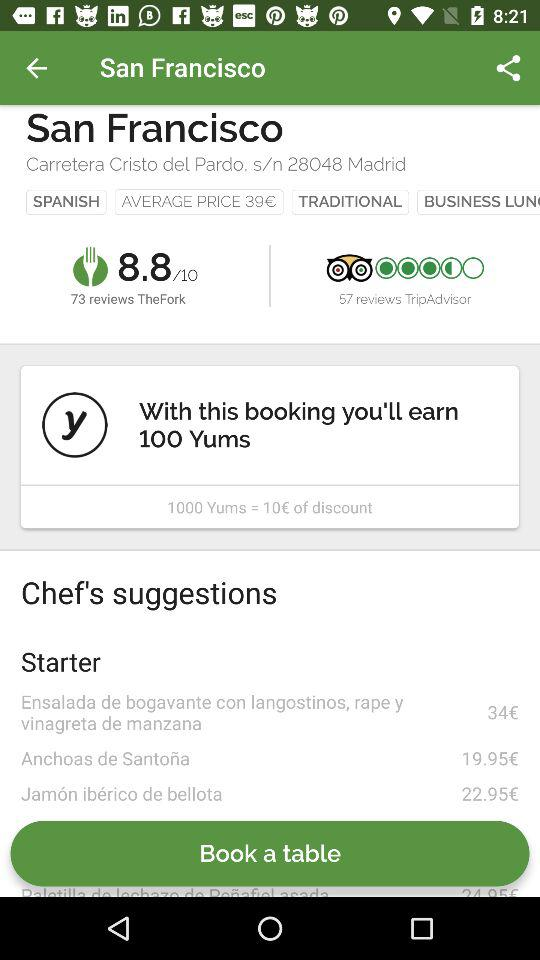What is the review of Trip Advisor?
When the provided information is insufficient, respond with <no answer>. <no answer> 